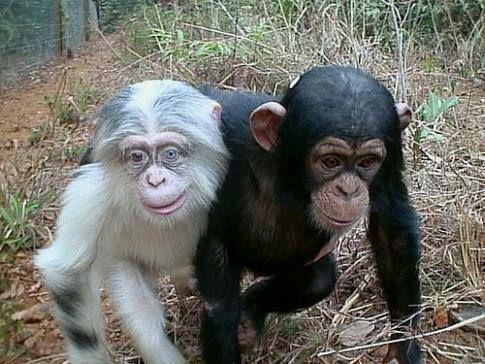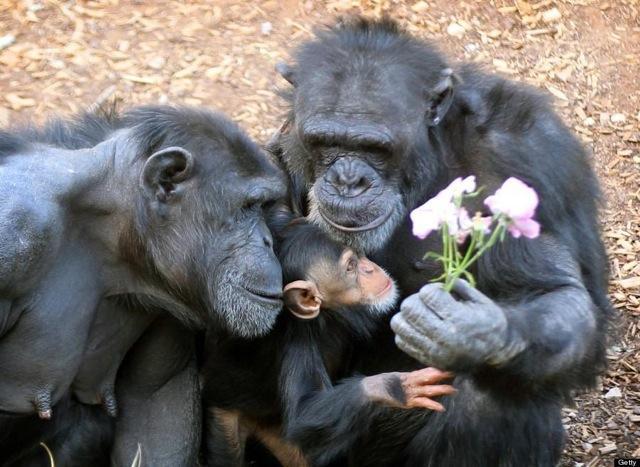The first image is the image on the left, the second image is the image on the right. Evaluate the accuracy of this statement regarding the images: "None of the images has more than two chimpanzees present.". Is it true? Answer yes or no. No. The first image is the image on the left, the second image is the image on the right. Given the left and right images, does the statement "The image on the right contains two chimpanzees." hold true? Answer yes or no. No. 